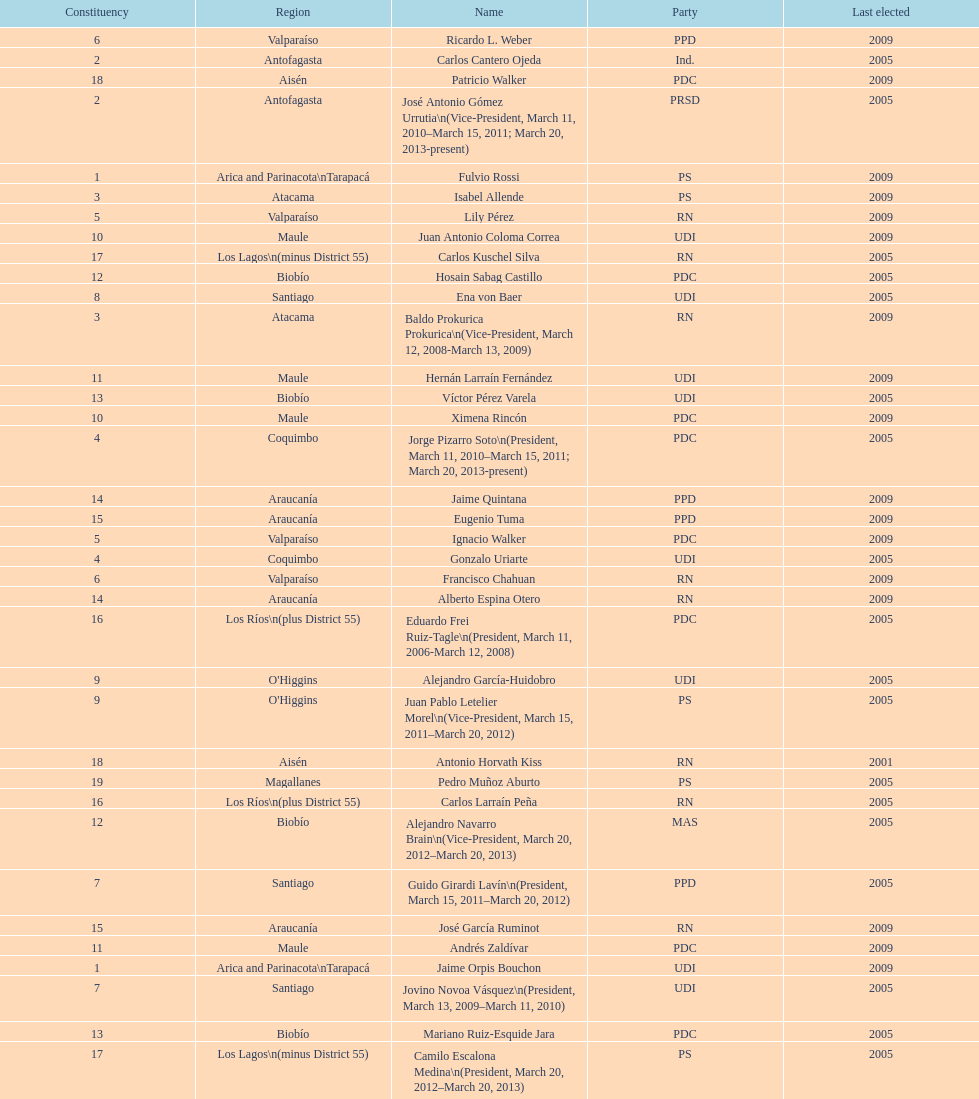Who was not last elected in either 2005 or 2009? Antonio Horvath Kiss. 